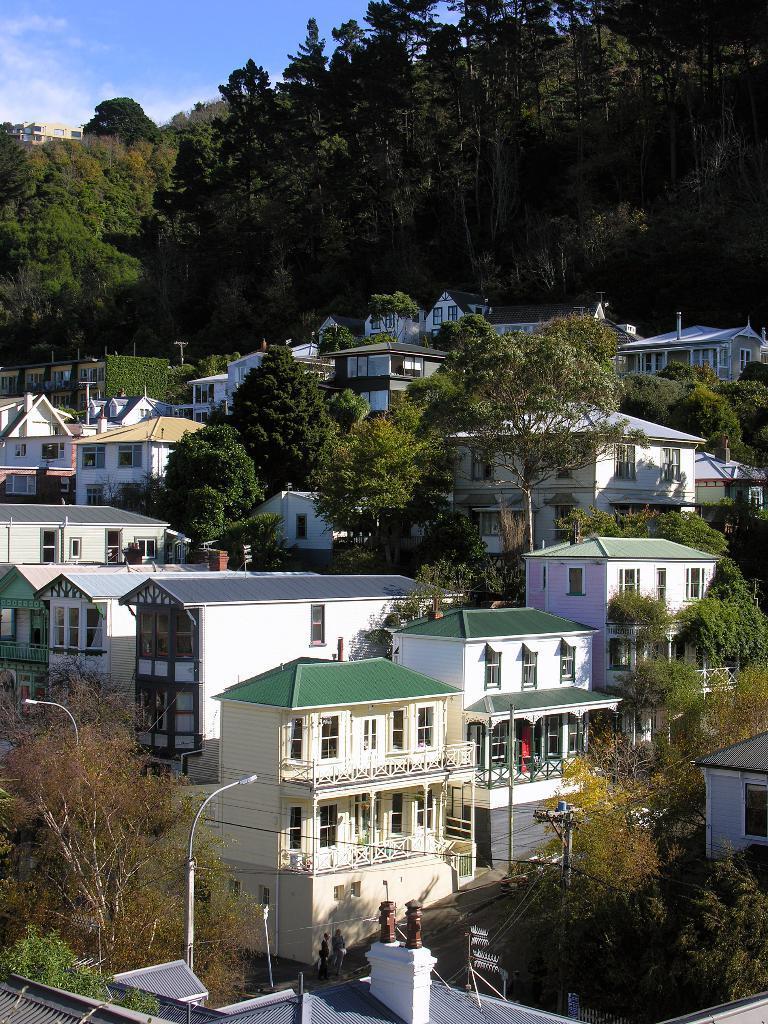Describe this image in one or two sentences. In the image we can see there are lot of buildings and there are lot of trees. 